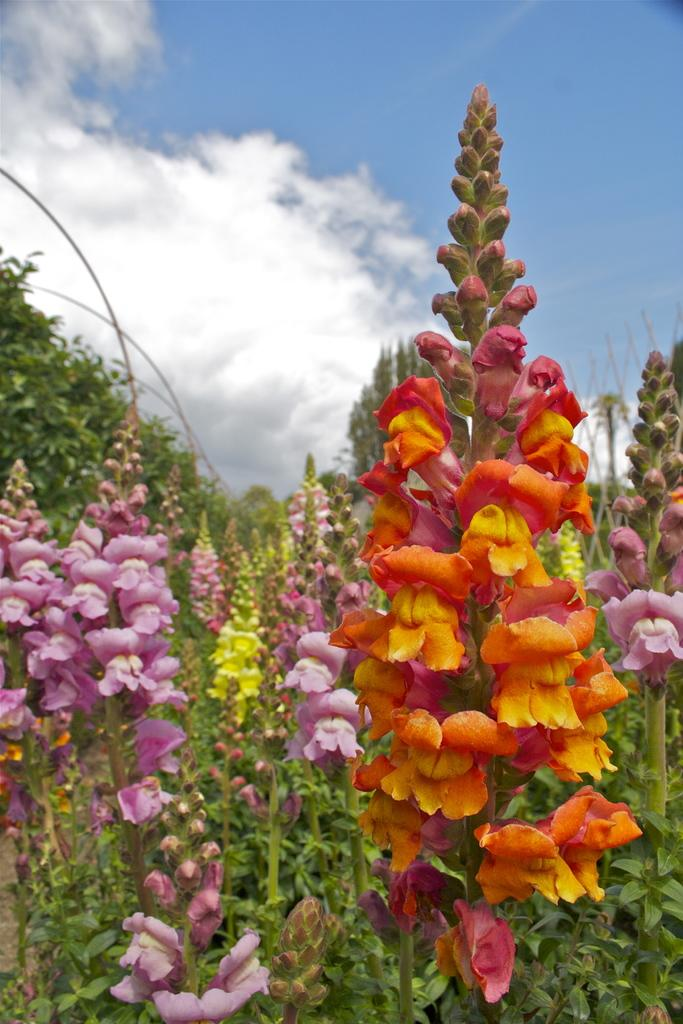What type of plants can be seen in the image? There are flowers in the image. What color is the sky in the image? The sky is blue in color. Can you describe the weather condition in the image? The sky is cloudy in the image. What type of temper does the cast have in the image? There is no cast or temper present in the image; it features flowers and a cloudy blue sky. What type of scale is used to weigh the flowers in the image? There is no scale present in the image, and the flowers are not being weighed. 